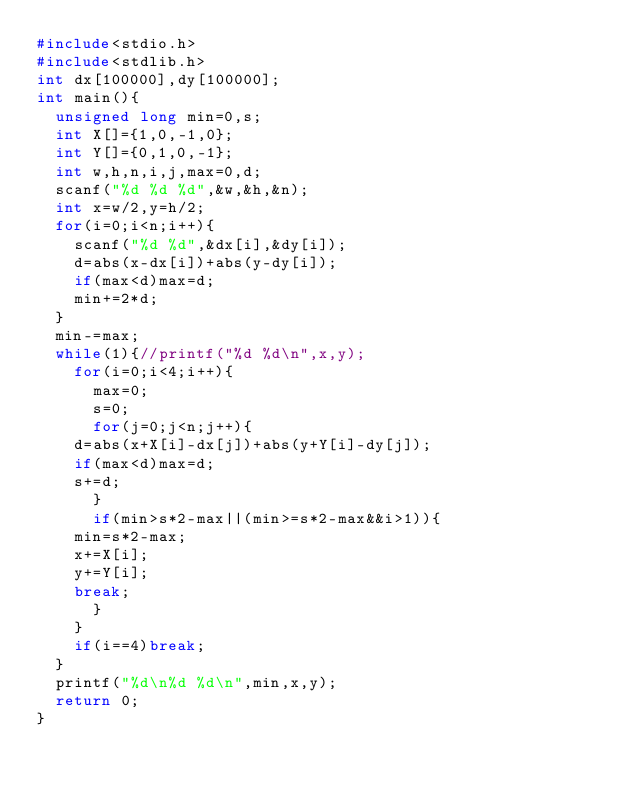<code> <loc_0><loc_0><loc_500><loc_500><_C_>#include<stdio.h>
#include<stdlib.h>
int dx[100000],dy[100000];
int main(){
  unsigned long min=0,s;
  int X[]={1,0,-1,0};
  int Y[]={0,1,0,-1};
  int w,h,n,i,j,max=0,d;
  scanf("%d %d %d",&w,&h,&n);
  int x=w/2,y=h/2;
  for(i=0;i<n;i++){
    scanf("%d %d",&dx[i],&dy[i]);
    d=abs(x-dx[i])+abs(y-dy[i]);
    if(max<d)max=d;
    min+=2*d;
  }
  min-=max;
  while(1){//printf("%d %d\n",x,y);
    for(i=0;i<4;i++){
      max=0;
      s=0;
      for(j=0;j<n;j++){
	d=abs(x+X[i]-dx[j])+abs(y+Y[i]-dy[j]);
	if(max<d)max=d;
	s+=d;
      }
      if(min>s*2-max||(min>=s*2-max&&i>1)){
	min=s*2-max;
	x+=X[i];
	y+=Y[i];
	break;
      }
    }
    if(i==4)break;
  }
  printf("%d\n%d %d\n",min,x,y);
  return 0;
}</code> 